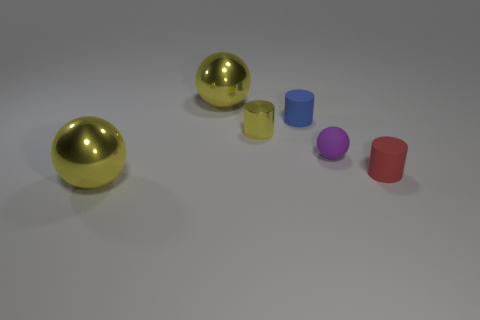How many shiny objects are to the right of the blue cylinder?
Keep it short and to the point. 0. Are there any small cyan things that have the same shape as the blue thing?
Your answer should be very brief. No. There is a metal cylinder that is the same size as the red thing; what is its color?
Your response must be concise. Yellow. Is the number of cylinders to the right of the small purple matte thing less than the number of small yellow shiny cylinders that are in front of the tiny yellow metal thing?
Your answer should be very brief. No. There is a rubber object behind the matte ball; is it the same size as the small red object?
Your answer should be compact. Yes. The red matte object on the right side of the blue matte object has what shape?
Ensure brevity in your answer.  Cylinder. Are there more yellow balls than tiny objects?
Offer a terse response. No. Is the color of the sphere that is in front of the rubber sphere the same as the tiny metallic cylinder?
Offer a terse response. Yes. What number of things are big yellow objects behind the small red matte object or things that are to the left of the small yellow metallic cylinder?
Provide a succinct answer. 2. What number of objects are on the left side of the small blue thing and behind the small shiny cylinder?
Provide a short and direct response. 1. 